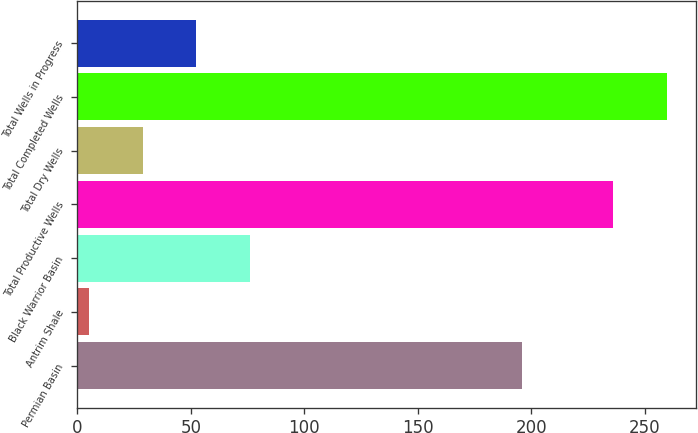Convert chart. <chart><loc_0><loc_0><loc_500><loc_500><bar_chart><fcel>Permian Basin<fcel>Antrim Shale<fcel>Black Warrior Basin<fcel>Total Productive Wells<fcel>Total Dry Wells<fcel>Total Completed Wells<fcel>Total Wells in Progress<nl><fcel>196<fcel>5<fcel>76.1<fcel>236<fcel>28.7<fcel>259.7<fcel>52.4<nl></chart> 